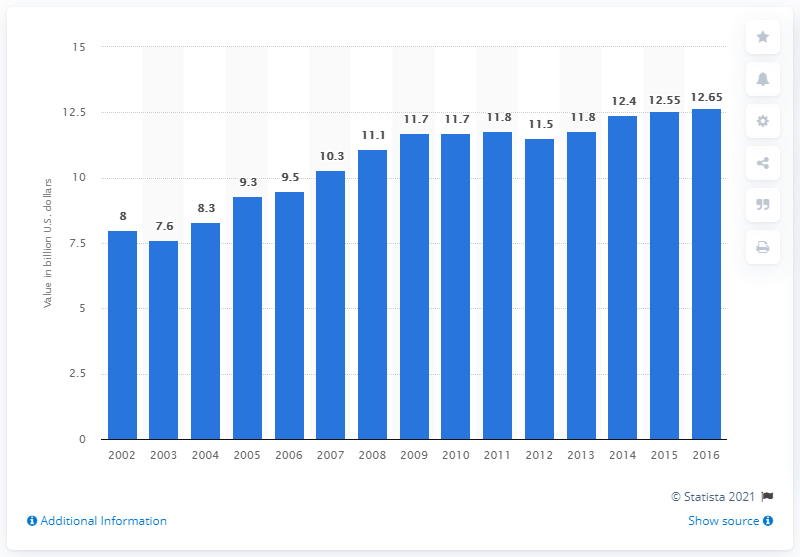Draw attention to some important aspects in this diagram. In 2016, the value of U.S. product shipments of bread was 12.65. 